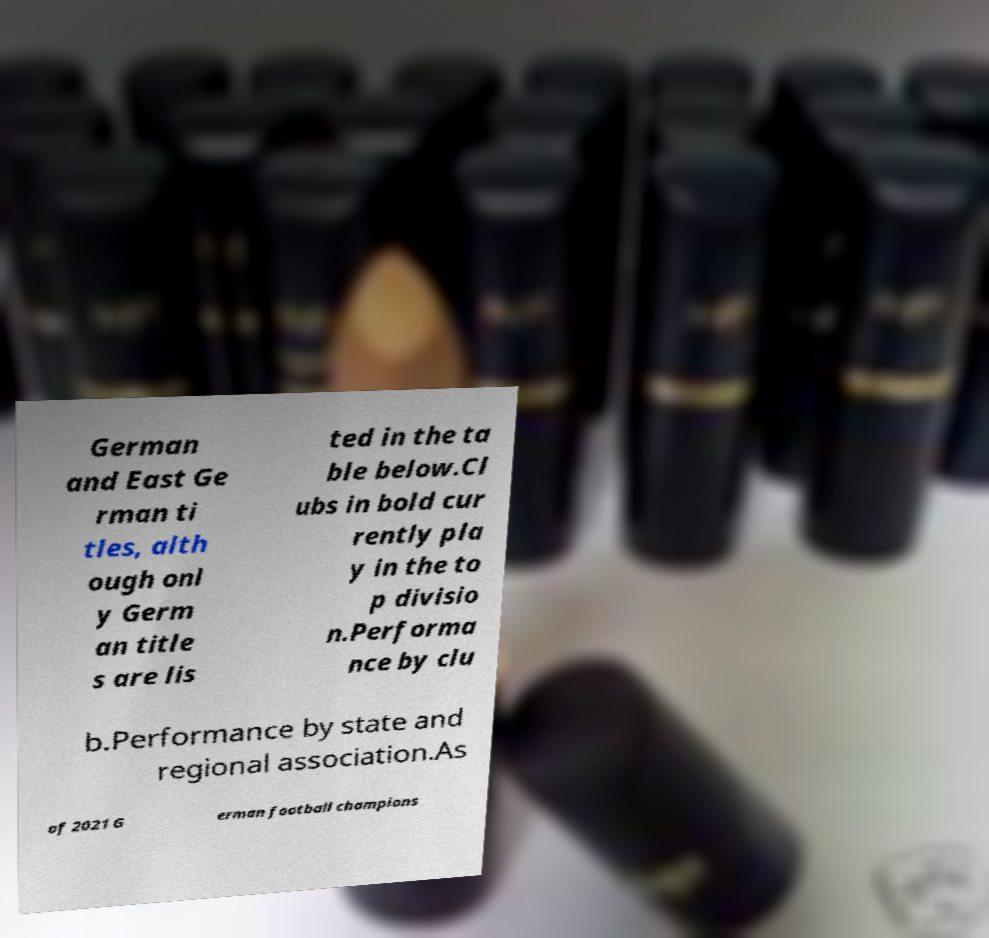There's text embedded in this image that I need extracted. Can you transcribe it verbatim? German and East Ge rman ti tles, alth ough onl y Germ an title s are lis ted in the ta ble below.Cl ubs in bold cur rently pla y in the to p divisio n.Performa nce by clu b.Performance by state and regional association.As of 2021 G erman football champions 